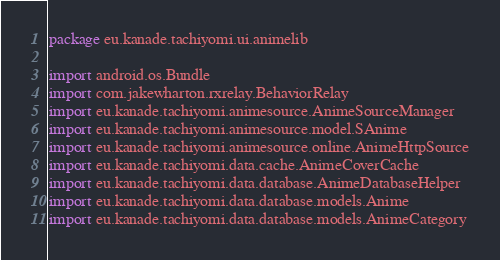Convert code to text. <code><loc_0><loc_0><loc_500><loc_500><_Kotlin_>package eu.kanade.tachiyomi.ui.animelib

import android.os.Bundle
import com.jakewharton.rxrelay.BehaviorRelay
import eu.kanade.tachiyomi.animesource.AnimeSourceManager
import eu.kanade.tachiyomi.animesource.model.SAnime
import eu.kanade.tachiyomi.animesource.online.AnimeHttpSource
import eu.kanade.tachiyomi.data.cache.AnimeCoverCache
import eu.kanade.tachiyomi.data.database.AnimeDatabaseHelper
import eu.kanade.tachiyomi.data.database.models.Anime
import eu.kanade.tachiyomi.data.database.models.AnimeCategory</code> 